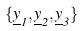<formula> <loc_0><loc_0><loc_500><loc_500>\{ \underline { y } _ { 1 } , \underline { y } _ { 2 } , \underline { y } _ { 3 } \}</formula> 